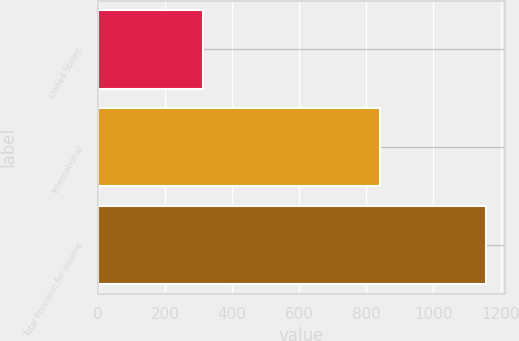Convert chart. <chart><loc_0><loc_0><loc_500><loc_500><bar_chart><fcel>United States<fcel>International<fcel>Total Provision for income<nl><fcel>314<fcel>841<fcel>1155<nl></chart> 